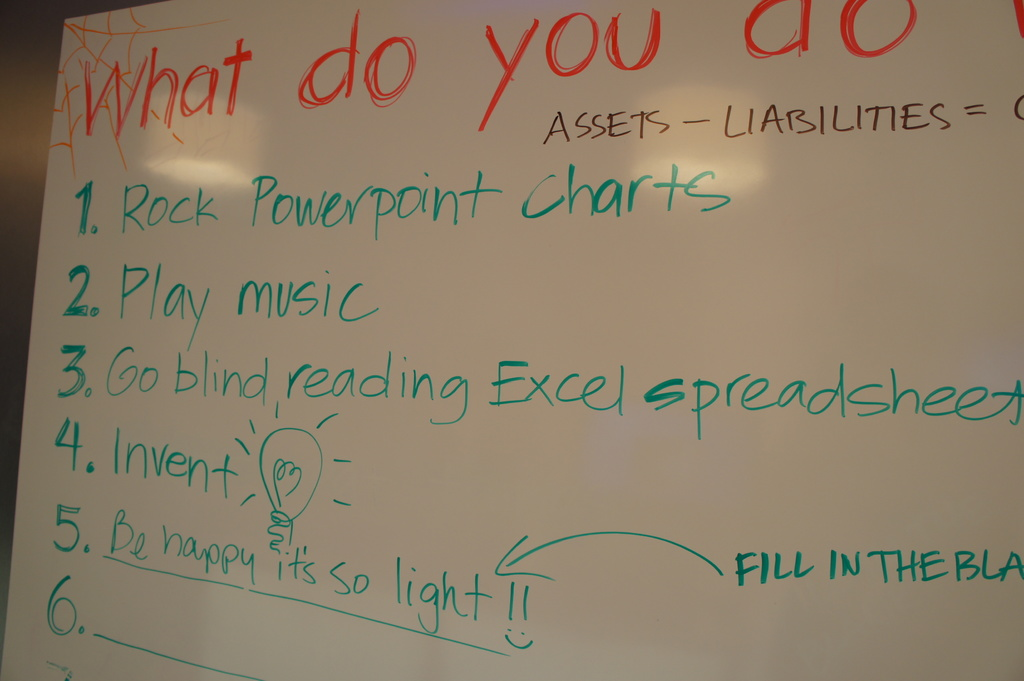Can you explain how 'Rock PowerPoint Charts' could be a practical solution for dealing with finances? 'Rock PowerPoint Charts' implies the use of visually engaging and impactful PowerPoint presentations to simplify complex financial data. This can be particularly useful in making abstract numbers more tangible and understandable, thus aiding decision-makers in grasping key financial concepts and facilitating clearer discussions. 